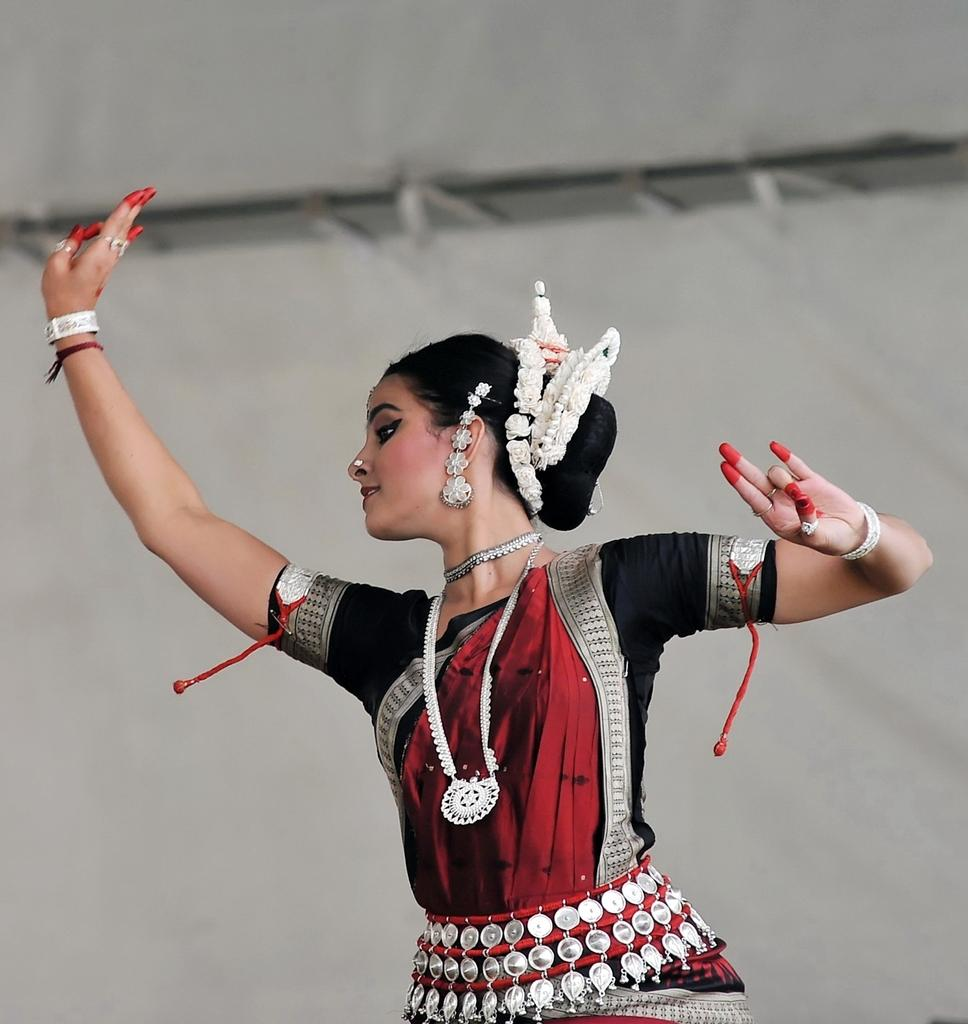Who is the main subject in the image? There is a woman in the image. What is the woman doing in the image? The woman is dancing. What can be seen in the background of the image? There is a white-colored curtain in the background of the image. What type of owl can be seen perched on the woman's shoulder in the image? There is no owl present in the image; the woman is dancing without any visible animals. 